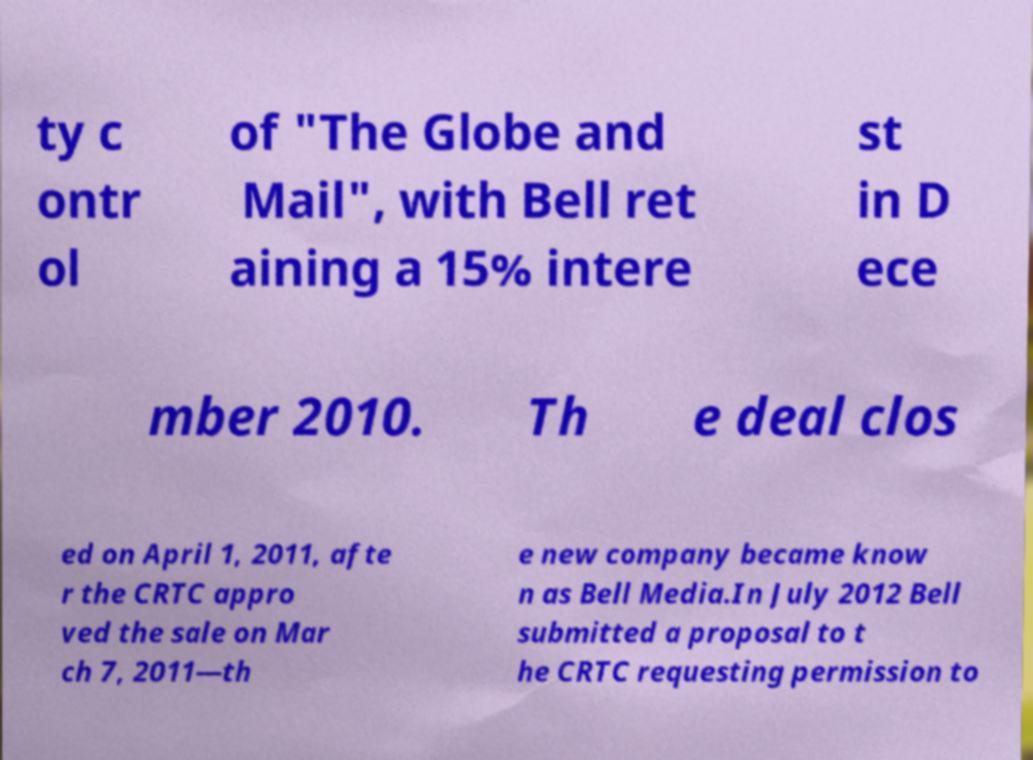I need the written content from this picture converted into text. Can you do that? ty c ontr ol of "The Globe and Mail", with Bell ret aining a 15% intere st in D ece mber 2010. Th e deal clos ed on April 1, 2011, afte r the CRTC appro ved the sale on Mar ch 7, 2011—th e new company became know n as Bell Media.In July 2012 Bell submitted a proposal to t he CRTC requesting permission to 